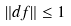Convert formula to latex. <formula><loc_0><loc_0><loc_500><loc_500>\| d f \| \leq 1</formula> 